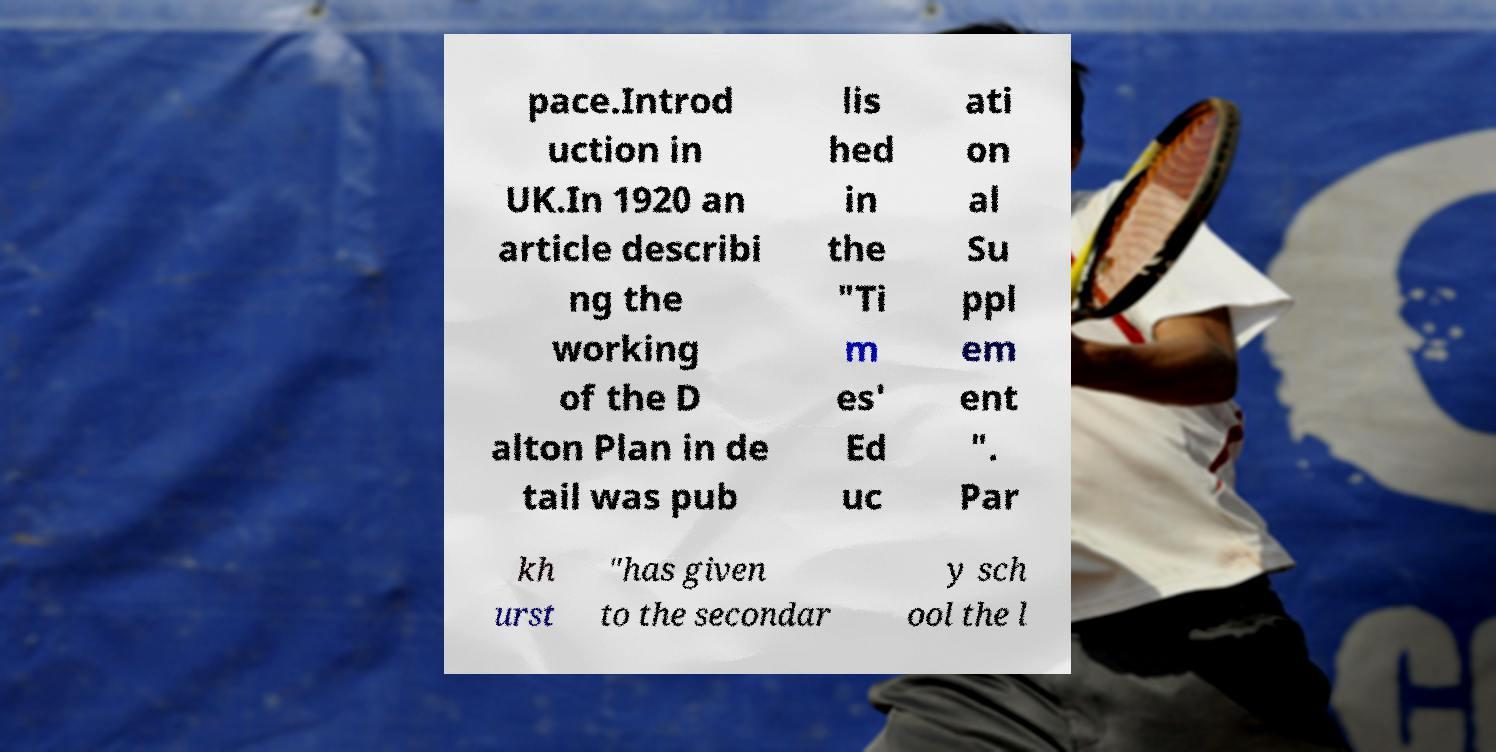There's text embedded in this image that I need extracted. Can you transcribe it verbatim? pace.Introd uction in UK.In 1920 an article describi ng the working of the D alton Plan in de tail was pub lis hed in the "Ti m es' Ed uc ati on al Su ppl em ent ". Par kh urst "has given to the secondar y sch ool the l 